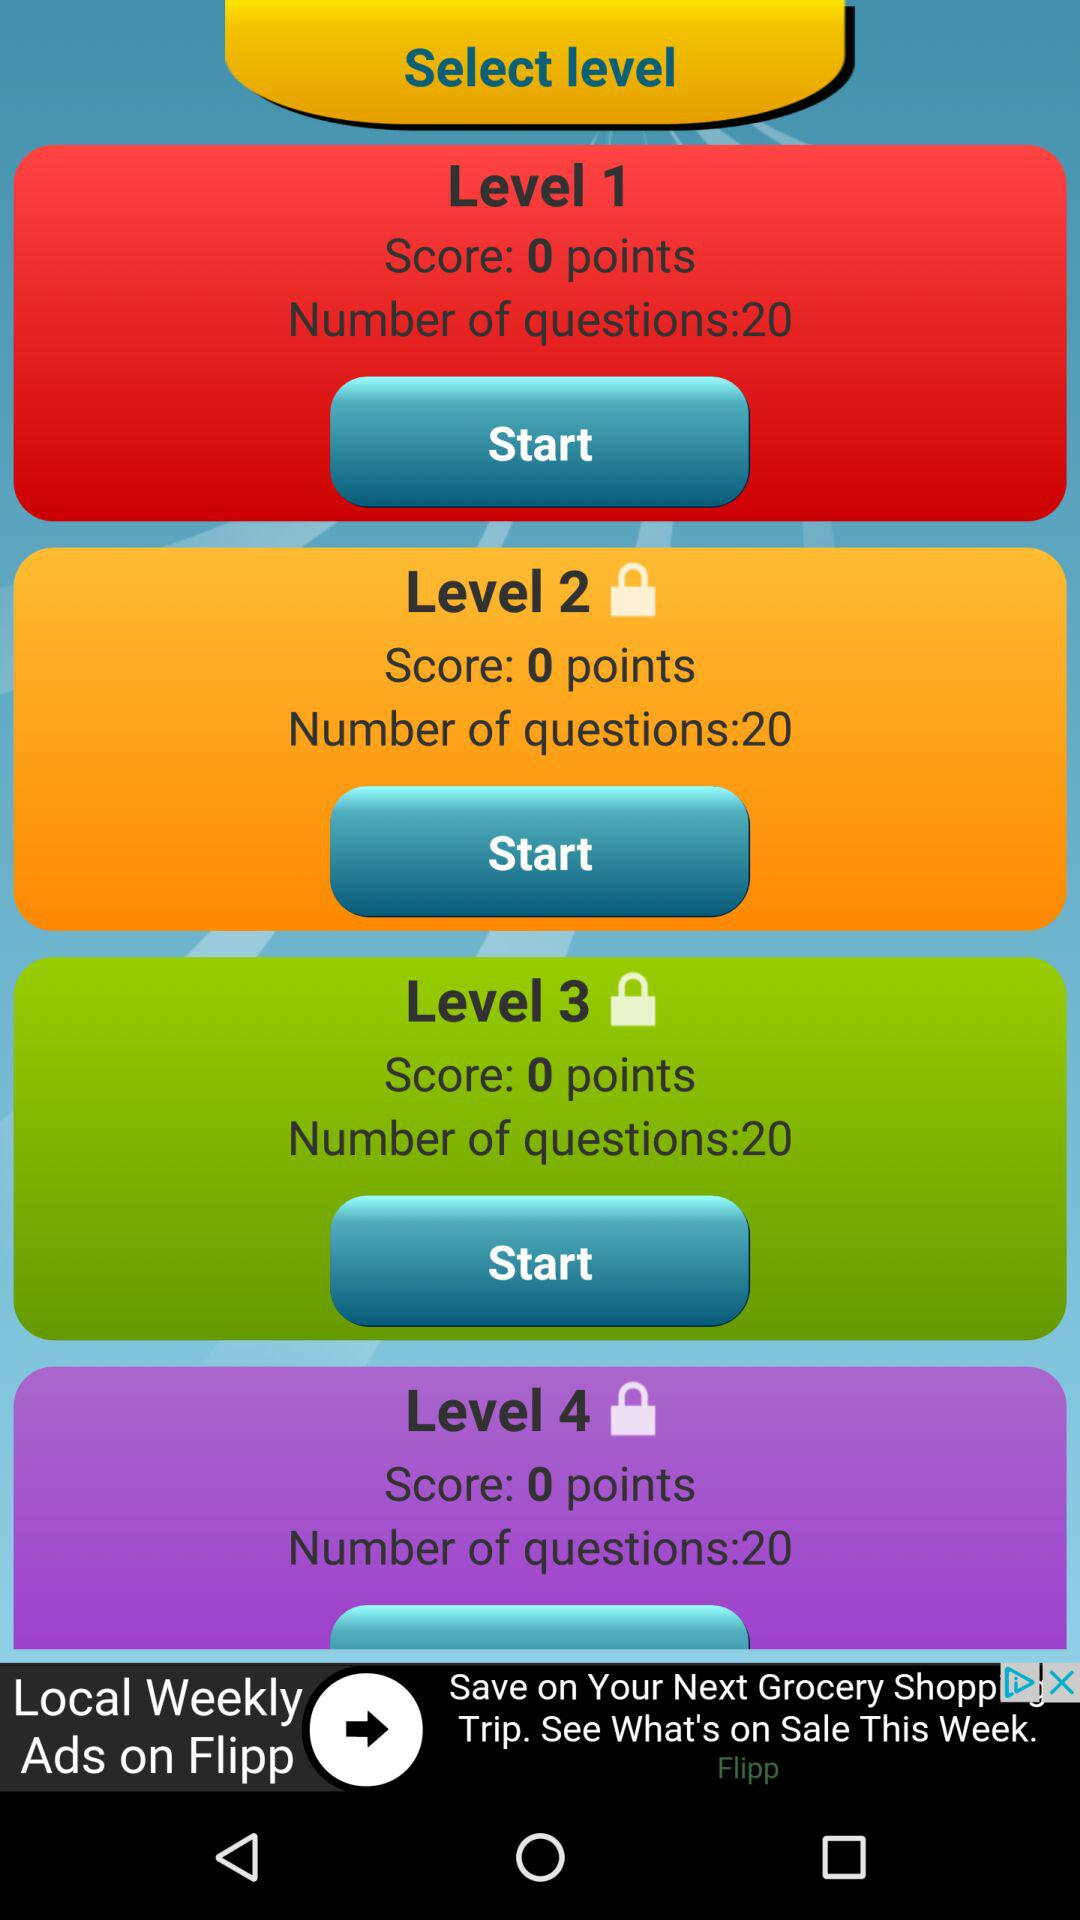What is the status of "Level 4"? The status is "locked". 